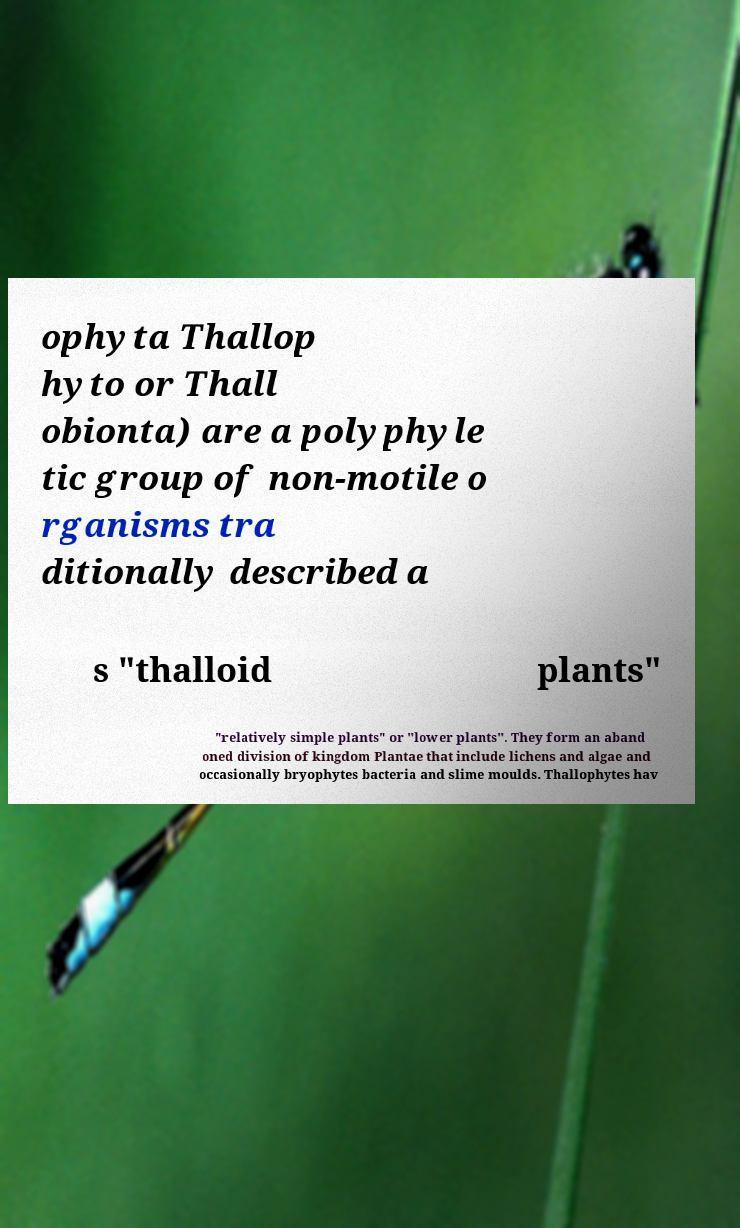Please read and relay the text visible in this image. What does it say? ophyta Thallop hyto or Thall obionta) are a polyphyle tic group of non-motile o rganisms tra ditionally described a s "thalloid plants" "relatively simple plants" or "lower plants". They form an aband oned division of kingdom Plantae that include lichens and algae and occasionally bryophytes bacteria and slime moulds. Thallophytes hav 